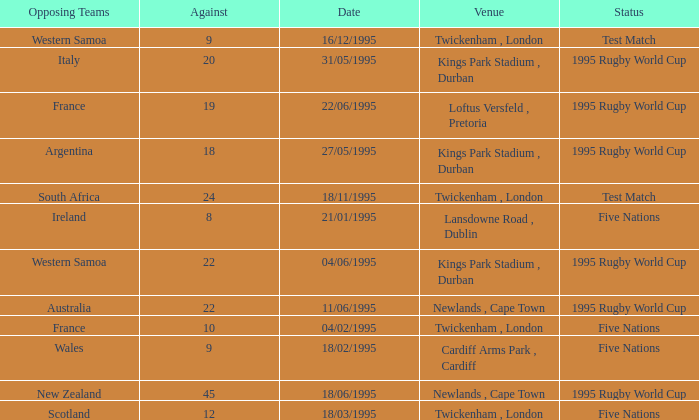What's the status with an against over 20 on 18/11/1995? Test Match. 